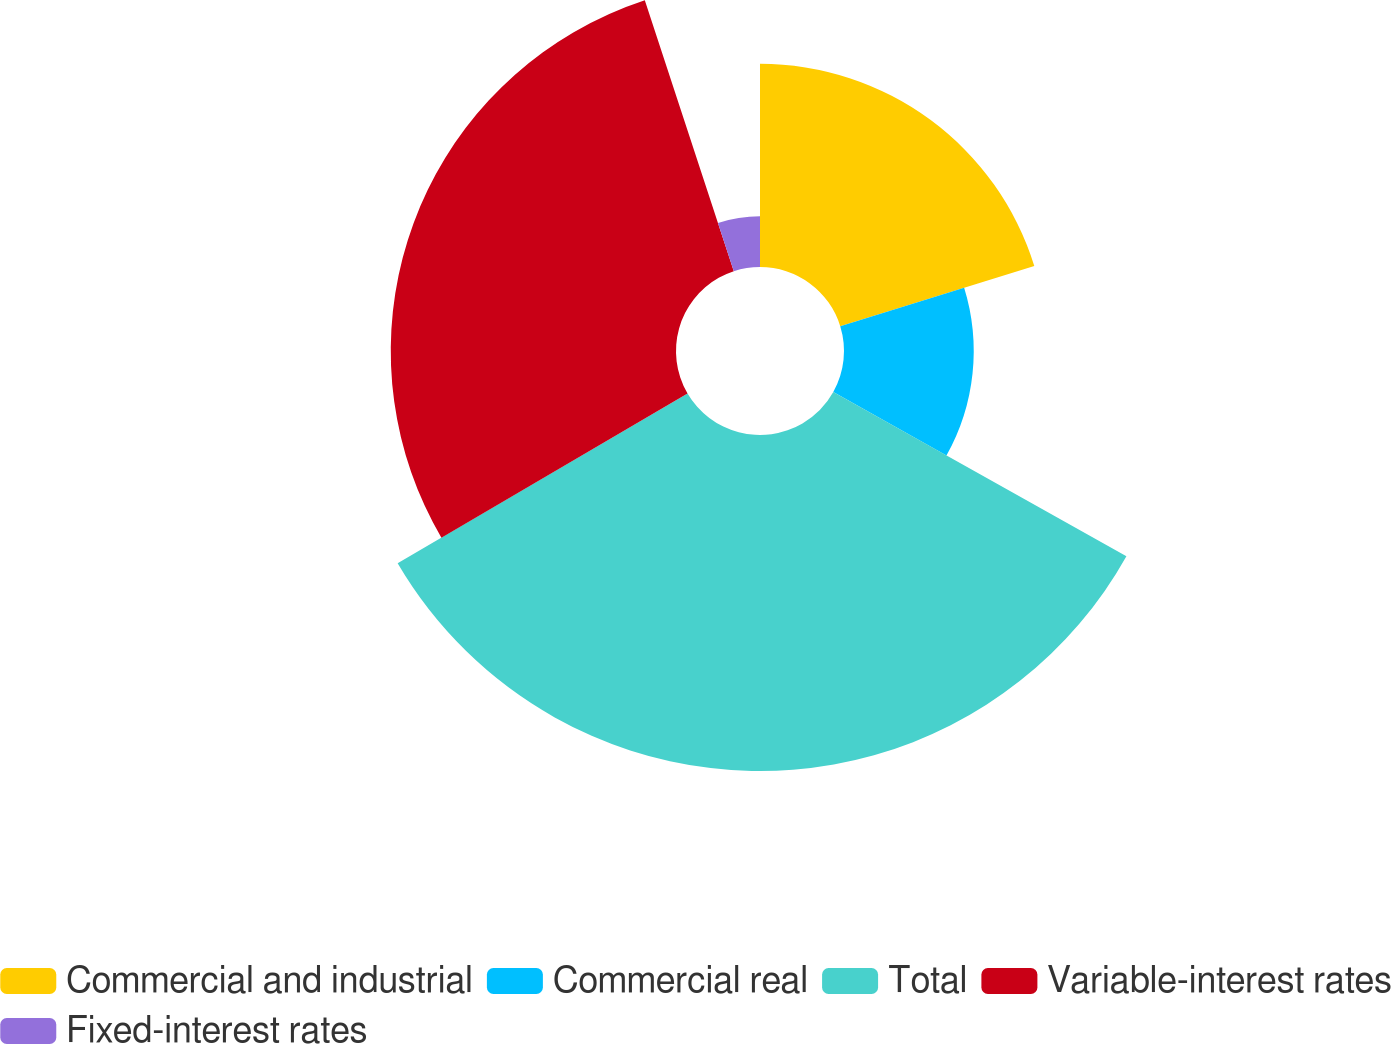Convert chart to OTSL. <chart><loc_0><loc_0><loc_500><loc_500><pie_chart><fcel>Commercial and industrial<fcel>Commercial real<fcel>Total<fcel>Variable-interest rates<fcel>Fixed-interest rates<nl><fcel>20.22%<fcel>12.91%<fcel>33.44%<fcel>28.39%<fcel>5.05%<nl></chart> 